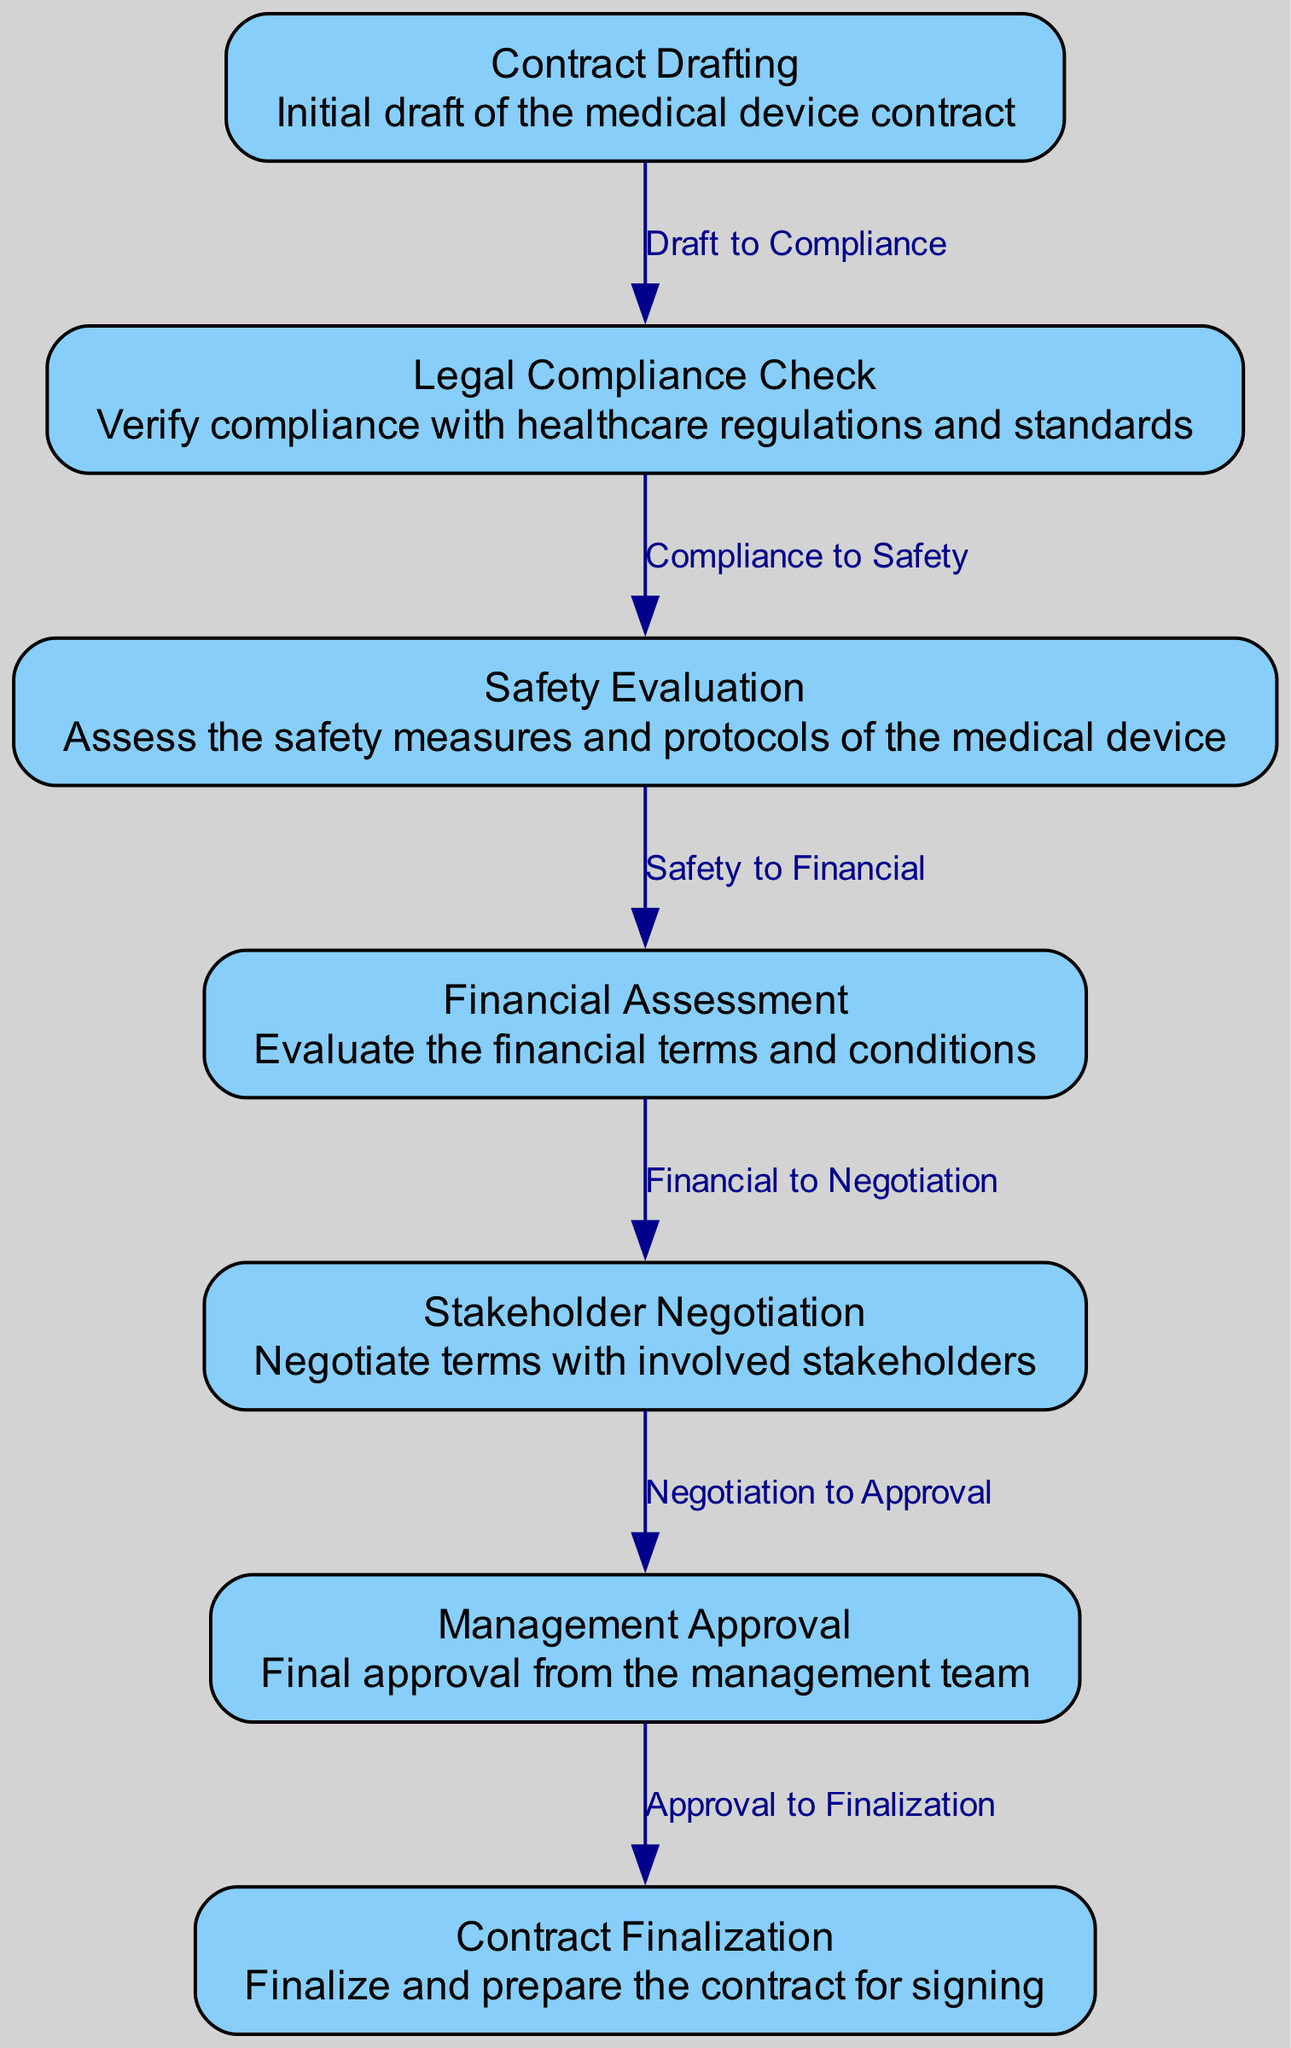What is the first step in the contract review process? The first step in the diagram is "Contract Drafting," which illustrates that the initial draft of the medical device contract is prepared before any reviews begin.
Answer: Contract Drafting How many nodes are present in the diagram? By counting the nodes listed in the provided data, there are a total of 7 nodes representing different stages of the contract review process.
Answer: 7 What follows the "Financial Assessment" stage? The diagram shows that the step following "Financial Assessment" is "Stakeholder Negotiation," indicating that after evaluating financial terms, negotiations occur with stakeholders.
Answer: Stakeholder Negotiation Which stage requires final approval from the management team? According to the flowchart, "Management Approval" is the stage that involves obtaining final approval from the management team before moving on to contract finalization.
Answer: Management Approval What is the relationship between "Safety Evaluation" and "Financial Assessment"? The diagram indicates a directed connection from "Safety Evaluation" to "Financial Assessment," signifying that financial evaluations occur after safety evaluations are complete.
Answer: Safety to Financial How many steps are there from the initial drafting to the finalization of the contract? Following the flow of the diagram from "Contract Drafting" to "Contract Finalization," there are a total of 6 steps connecting these two stages.
Answer: 6 What type of checks are done during the "Legal Compliance Check"? The "Legal Compliance Check" stage is dedicated to verifying compliance with healthcare regulations and standards, focusing on legal aspects before proceeding further.
Answer: Healthcare regulations Which stage includes negotiation with stakeholders? "Stakeholder Negotiation" is the specific stage within the diagram that illustrates the process where terms are negotiated with the involved stakeholders before obtaining management approval.
Answer: Stakeholder Negotiation 